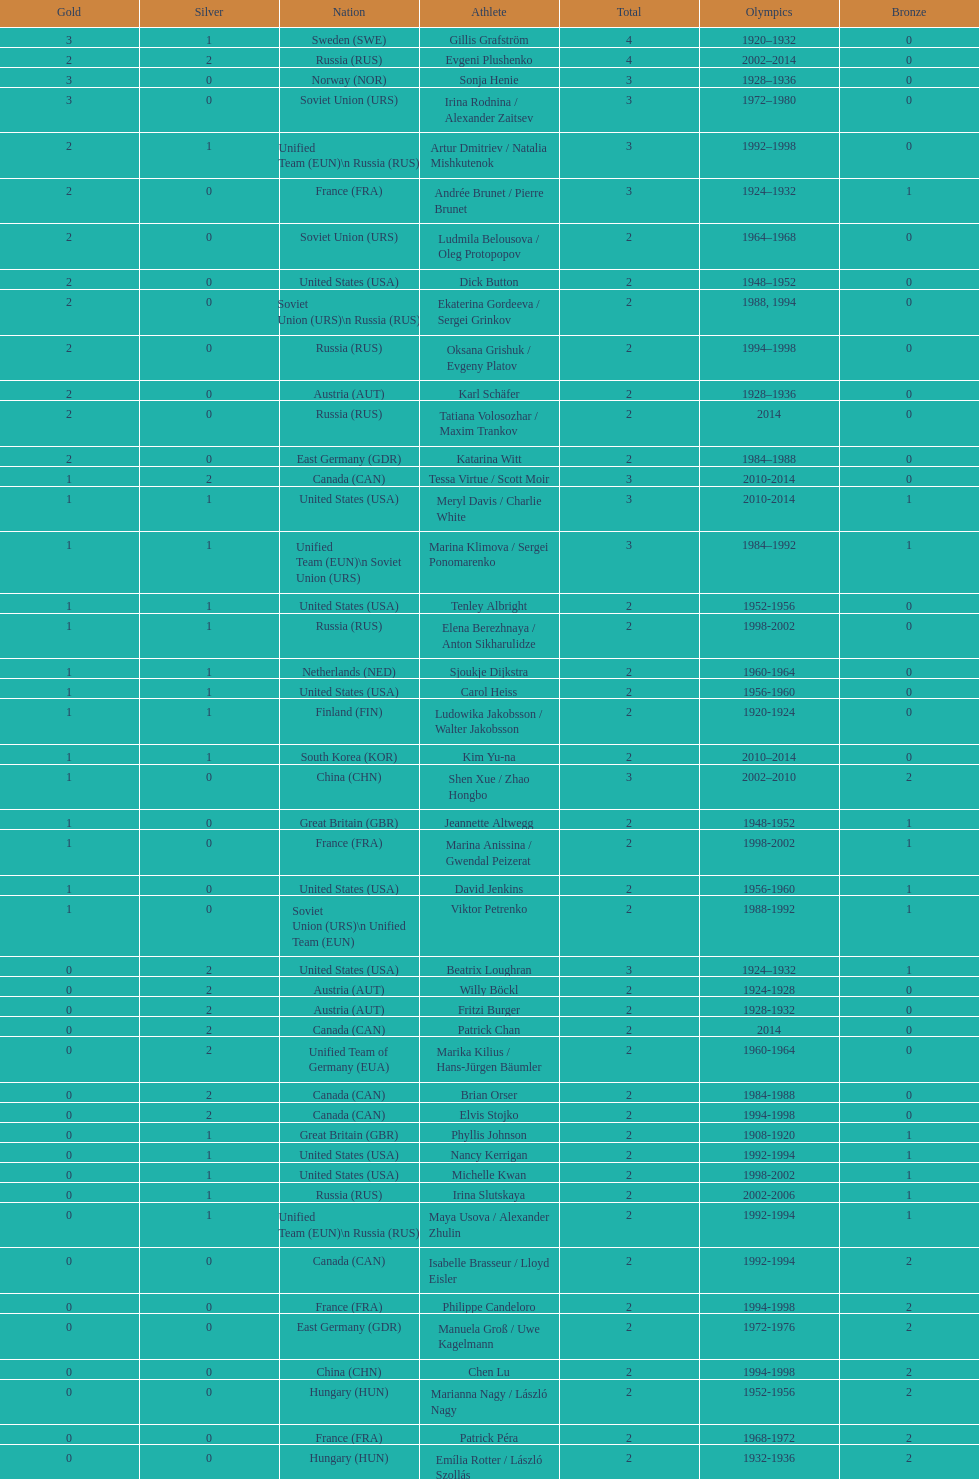Which sportsman hails from south korea post-2010? Kim Yu-na. 